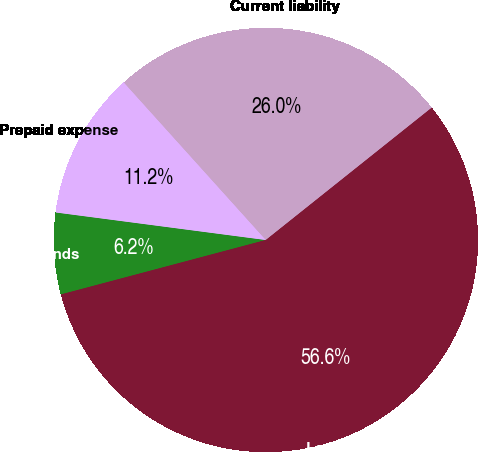Convert chart. <chart><loc_0><loc_0><loc_500><loc_500><pie_chart><fcel>In thousands<fcel>Prepaid expense<fcel>Current liability<fcel>Long-term liability<nl><fcel>6.21%<fcel>11.25%<fcel>25.96%<fcel>56.58%<nl></chart> 